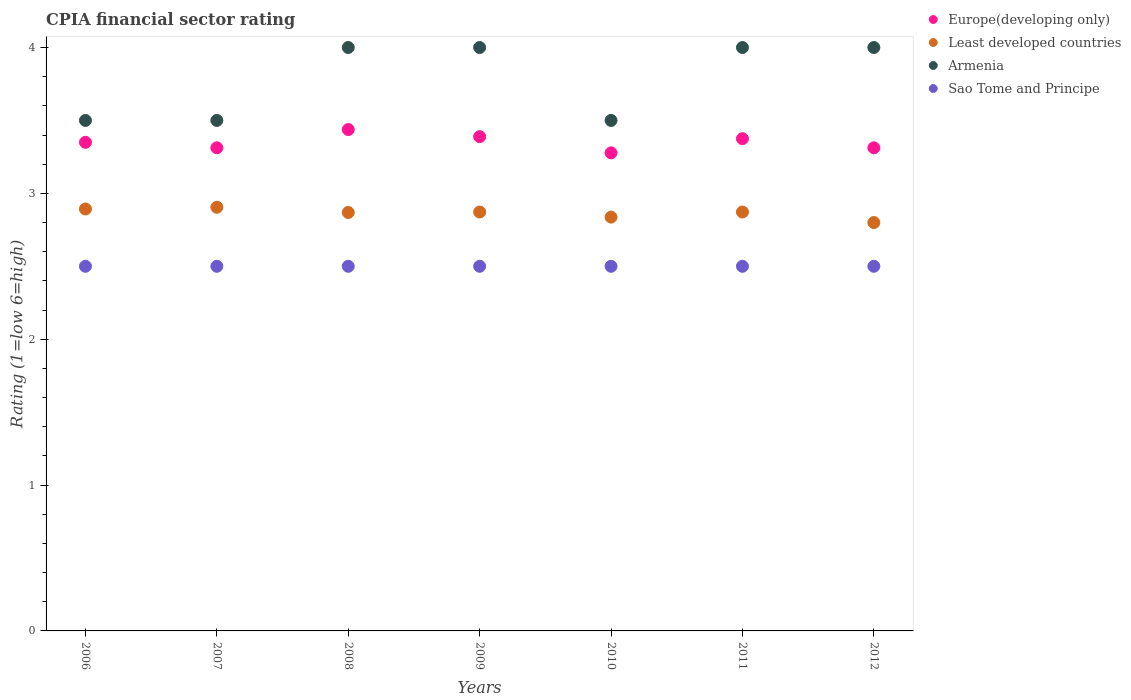What is the CPIA rating in Least developed countries in 2006?
Offer a very short reply. 2.89. Across all years, what is the maximum CPIA rating in Europe(developing only)?
Keep it short and to the point. 3.44. In which year was the CPIA rating in Europe(developing only) maximum?
Offer a very short reply. 2008. In which year was the CPIA rating in Sao Tome and Principe minimum?
Your answer should be compact. 2006. What is the total CPIA rating in Europe(developing only) in the graph?
Make the answer very short. 23.45. What is the difference between the CPIA rating in Sao Tome and Principe in 2007 and that in 2009?
Make the answer very short. 0. What is the difference between the CPIA rating in Armenia in 2011 and the CPIA rating in Sao Tome and Principe in 2012?
Your answer should be compact. 1.5. What is the average CPIA rating in Sao Tome and Principe per year?
Offer a terse response. 2.5. In the year 2009, what is the difference between the CPIA rating in Europe(developing only) and CPIA rating in Least developed countries?
Provide a succinct answer. 0.52. In how many years, is the CPIA rating in Sao Tome and Principe greater than 0.4?
Your answer should be compact. 7. What is the ratio of the CPIA rating in Europe(developing only) in 2006 to that in 2007?
Your response must be concise. 1.01. Is the CPIA rating in Armenia in 2006 less than that in 2011?
Your response must be concise. Yes. Is the difference between the CPIA rating in Europe(developing only) in 2010 and 2011 greater than the difference between the CPIA rating in Least developed countries in 2010 and 2011?
Ensure brevity in your answer.  No. What is the difference between the highest and the second highest CPIA rating in Armenia?
Your response must be concise. 0. What is the difference between the highest and the lowest CPIA rating in Europe(developing only)?
Your answer should be very brief. 0.16. In how many years, is the CPIA rating in Europe(developing only) greater than the average CPIA rating in Europe(developing only) taken over all years?
Ensure brevity in your answer.  3. Is it the case that in every year, the sum of the CPIA rating in Sao Tome and Principe and CPIA rating in Europe(developing only)  is greater than the CPIA rating in Armenia?
Your response must be concise. Yes. Does the CPIA rating in Armenia monotonically increase over the years?
Offer a terse response. No. How many dotlines are there?
Your answer should be very brief. 4. What is the difference between two consecutive major ticks on the Y-axis?
Provide a short and direct response. 1. Are the values on the major ticks of Y-axis written in scientific E-notation?
Ensure brevity in your answer.  No. How many legend labels are there?
Your response must be concise. 4. What is the title of the graph?
Make the answer very short. CPIA financial sector rating. Does "World" appear as one of the legend labels in the graph?
Your answer should be very brief. No. What is the Rating (1=low 6=high) in Europe(developing only) in 2006?
Offer a very short reply. 3.35. What is the Rating (1=low 6=high) in Least developed countries in 2006?
Provide a short and direct response. 2.89. What is the Rating (1=low 6=high) in Europe(developing only) in 2007?
Make the answer very short. 3.31. What is the Rating (1=low 6=high) in Least developed countries in 2007?
Provide a short and direct response. 2.9. What is the Rating (1=low 6=high) of Sao Tome and Principe in 2007?
Your response must be concise. 2.5. What is the Rating (1=low 6=high) in Europe(developing only) in 2008?
Offer a terse response. 3.44. What is the Rating (1=low 6=high) in Least developed countries in 2008?
Ensure brevity in your answer.  2.87. What is the Rating (1=low 6=high) in Sao Tome and Principe in 2008?
Your answer should be compact. 2.5. What is the Rating (1=low 6=high) of Europe(developing only) in 2009?
Offer a very short reply. 3.39. What is the Rating (1=low 6=high) of Least developed countries in 2009?
Your response must be concise. 2.87. What is the Rating (1=low 6=high) of Sao Tome and Principe in 2009?
Keep it short and to the point. 2.5. What is the Rating (1=low 6=high) of Europe(developing only) in 2010?
Keep it short and to the point. 3.28. What is the Rating (1=low 6=high) in Least developed countries in 2010?
Keep it short and to the point. 2.84. What is the Rating (1=low 6=high) of Armenia in 2010?
Your response must be concise. 3.5. What is the Rating (1=low 6=high) of Europe(developing only) in 2011?
Provide a succinct answer. 3.38. What is the Rating (1=low 6=high) of Least developed countries in 2011?
Provide a succinct answer. 2.87. What is the Rating (1=low 6=high) in Armenia in 2011?
Offer a terse response. 4. What is the Rating (1=low 6=high) in Sao Tome and Principe in 2011?
Your response must be concise. 2.5. What is the Rating (1=low 6=high) in Europe(developing only) in 2012?
Make the answer very short. 3.31. What is the Rating (1=low 6=high) in Least developed countries in 2012?
Make the answer very short. 2.8. What is the Rating (1=low 6=high) in Armenia in 2012?
Offer a terse response. 4. Across all years, what is the maximum Rating (1=low 6=high) of Europe(developing only)?
Offer a terse response. 3.44. Across all years, what is the maximum Rating (1=low 6=high) in Least developed countries?
Your answer should be compact. 2.9. Across all years, what is the minimum Rating (1=low 6=high) of Europe(developing only)?
Ensure brevity in your answer.  3.28. Across all years, what is the minimum Rating (1=low 6=high) in Least developed countries?
Give a very brief answer. 2.8. Across all years, what is the minimum Rating (1=low 6=high) of Armenia?
Your response must be concise. 3.5. Across all years, what is the minimum Rating (1=low 6=high) in Sao Tome and Principe?
Provide a short and direct response. 2.5. What is the total Rating (1=low 6=high) of Europe(developing only) in the graph?
Keep it short and to the point. 23.45. What is the total Rating (1=low 6=high) of Least developed countries in the graph?
Provide a short and direct response. 20.05. What is the total Rating (1=low 6=high) in Armenia in the graph?
Offer a very short reply. 26.5. What is the total Rating (1=low 6=high) of Sao Tome and Principe in the graph?
Make the answer very short. 17.5. What is the difference between the Rating (1=low 6=high) of Europe(developing only) in 2006 and that in 2007?
Offer a very short reply. 0.04. What is the difference between the Rating (1=low 6=high) in Least developed countries in 2006 and that in 2007?
Provide a succinct answer. -0.01. What is the difference between the Rating (1=low 6=high) of Europe(developing only) in 2006 and that in 2008?
Offer a very short reply. -0.09. What is the difference between the Rating (1=low 6=high) of Least developed countries in 2006 and that in 2008?
Provide a succinct answer. 0.02. What is the difference between the Rating (1=low 6=high) in Sao Tome and Principe in 2006 and that in 2008?
Your response must be concise. 0. What is the difference between the Rating (1=low 6=high) in Europe(developing only) in 2006 and that in 2009?
Ensure brevity in your answer.  -0.04. What is the difference between the Rating (1=low 6=high) in Least developed countries in 2006 and that in 2009?
Offer a very short reply. 0.02. What is the difference between the Rating (1=low 6=high) of Armenia in 2006 and that in 2009?
Provide a succinct answer. -0.5. What is the difference between the Rating (1=low 6=high) of Sao Tome and Principe in 2006 and that in 2009?
Ensure brevity in your answer.  0. What is the difference between the Rating (1=low 6=high) of Europe(developing only) in 2006 and that in 2010?
Keep it short and to the point. 0.07. What is the difference between the Rating (1=low 6=high) of Least developed countries in 2006 and that in 2010?
Your answer should be very brief. 0.06. What is the difference between the Rating (1=low 6=high) of Europe(developing only) in 2006 and that in 2011?
Provide a succinct answer. -0.03. What is the difference between the Rating (1=low 6=high) of Least developed countries in 2006 and that in 2011?
Your answer should be very brief. 0.02. What is the difference between the Rating (1=low 6=high) of Sao Tome and Principe in 2006 and that in 2011?
Ensure brevity in your answer.  0. What is the difference between the Rating (1=low 6=high) in Europe(developing only) in 2006 and that in 2012?
Make the answer very short. 0.04. What is the difference between the Rating (1=low 6=high) in Least developed countries in 2006 and that in 2012?
Your answer should be compact. 0.09. What is the difference between the Rating (1=low 6=high) of Armenia in 2006 and that in 2012?
Make the answer very short. -0.5. What is the difference between the Rating (1=low 6=high) in Sao Tome and Principe in 2006 and that in 2012?
Your answer should be very brief. 0. What is the difference between the Rating (1=low 6=high) of Europe(developing only) in 2007 and that in 2008?
Ensure brevity in your answer.  -0.12. What is the difference between the Rating (1=low 6=high) in Least developed countries in 2007 and that in 2008?
Provide a succinct answer. 0.04. What is the difference between the Rating (1=low 6=high) of Armenia in 2007 and that in 2008?
Offer a terse response. -0.5. What is the difference between the Rating (1=low 6=high) of Europe(developing only) in 2007 and that in 2009?
Keep it short and to the point. -0.08. What is the difference between the Rating (1=low 6=high) in Least developed countries in 2007 and that in 2009?
Your answer should be very brief. 0.03. What is the difference between the Rating (1=low 6=high) of Armenia in 2007 and that in 2009?
Your response must be concise. -0.5. What is the difference between the Rating (1=low 6=high) in Europe(developing only) in 2007 and that in 2010?
Your response must be concise. 0.03. What is the difference between the Rating (1=low 6=high) in Least developed countries in 2007 and that in 2010?
Ensure brevity in your answer.  0.07. What is the difference between the Rating (1=low 6=high) in Sao Tome and Principe in 2007 and that in 2010?
Your answer should be very brief. 0. What is the difference between the Rating (1=low 6=high) of Europe(developing only) in 2007 and that in 2011?
Provide a short and direct response. -0.06. What is the difference between the Rating (1=low 6=high) of Least developed countries in 2007 and that in 2011?
Make the answer very short. 0.03. What is the difference between the Rating (1=low 6=high) of Europe(developing only) in 2007 and that in 2012?
Provide a short and direct response. 0. What is the difference between the Rating (1=low 6=high) of Least developed countries in 2007 and that in 2012?
Keep it short and to the point. 0.1. What is the difference between the Rating (1=low 6=high) in Armenia in 2007 and that in 2012?
Offer a terse response. -0.5. What is the difference between the Rating (1=low 6=high) of Europe(developing only) in 2008 and that in 2009?
Keep it short and to the point. 0.05. What is the difference between the Rating (1=low 6=high) of Least developed countries in 2008 and that in 2009?
Your answer should be very brief. -0. What is the difference between the Rating (1=low 6=high) in Sao Tome and Principe in 2008 and that in 2009?
Offer a very short reply. 0. What is the difference between the Rating (1=low 6=high) in Europe(developing only) in 2008 and that in 2010?
Make the answer very short. 0.16. What is the difference between the Rating (1=low 6=high) in Least developed countries in 2008 and that in 2010?
Keep it short and to the point. 0.03. What is the difference between the Rating (1=low 6=high) in Armenia in 2008 and that in 2010?
Keep it short and to the point. 0.5. What is the difference between the Rating (1=low 6=high) of Europe(developing only) in 2008 and that in 2011?
Provide a succinct answer. 0.06. What is the difference between the Rating (1=low 6=high) of Least developed countries in 2008 and that in 2011?
Keep it short and to the point. -0. What is the difference between the Rating (1=low 6=high) in Sao Tome and Principe in 2008 and that in 2011?
Your response must be concise. 0. What is the difference between the Rating (1=low 6=high) of Europe(developing only) in 2008 and that in 2012?
Provide a succinct answer. 0.12. What is the difference between the Rating (1=low 6=high) in Least developed countries in 2008 and that in 2012?
Give a very brief answer. 0.07. What is the difference between the Rating (1=low 6=high) of Armenia in 2008 and that in 2012?
Ensure brevity in your answer.  0. What is the difference between the Rating (1=low 6=high) in Sao Tome and Principe in 2008 and that in 2012?
Your answer should be compact. 0. What is the difference between the Rating (1=low 6=high) in Least developed countries in 2009 and that in 2010?
Your answer should be very brief. 0.03. What is the difference between the Rating (1=low 6=high) in Armenia in 2009 and that in 2010?
Your answer should be compact. 0.5. What is the difference between the Rating (1=low 6=high) in Europe(developing only) in 2009 and that in 2011?
Your answer should be very brief. 0.01. What is the difference between the Rating (1=low 6=high) in Least developed countries in 2009 and that in 2011?
Offer a very short reply. 0. What is the difference between the Rating (1=low 6=high) of Armenia in 2009 and that in 2011?
Make the answer very short. 0. What is the difference between the Rating (1=low 6=high) in Sao Tome and Principe in 2009 and that in 2011?
Provide a succinct answer. 0. What is the difference between the Rating (1=low 6=high) in Europe(developing only) in 2009 and that in 2012?
Make the answer very short. 0.08. What is the difference between the Rating (1=low 6=high) in Least developed countries in 2009 and that in 2012?
Your response must be concise. 0.07. What is the difference between the Rating (1=low 6=high) of Armenia in 2009 and that in 2012?
Provide a short and direct response. 0. What is the difference between the Rating (1=low 6=high) in Europe(developing only) in 2010 and that in 2011?
Your answer should be compact. -0.1. What is the difference between the Rating (1=low 6=high) in Least developed countries in 2010 and that in 2011?
Your response must be concise. -0.03. What is the difference between the Rating (1=low 6=high) in Armenia in 2010 and that in 2011?
Provide a short and direct response. -0.5. What is the difference between the Rating (1=low 6=high) of Sao Tome and Principe in 2010 and that in 2011?
Your answer should be very brief. 0. What is the difference between the Rating (1=low 6=high) of Europe(developing only) in 2010 and that in 2012?
Your answer should be compact. -0.03. What is the difference between the Rating (1=low 6=high) of Least developed countries in 2010 and that in 2012?
Offer a very short reply. 0.04. What is the difference between the Rating (1=low 6=high) of Europe(developing only) in 2011 and that in 2012?
Provide a short and direct response. 0.06. What is the difference between the Rating (1=low 6=high) in Least developed countries in 2011 and that in 2012?
Your answer should be very brief. 0.07. What is the difference between the Rating (1=low 6=high) in Europe(developing only) in 2006 and the Rating (1=low 6=high) in Least developed countries in 2007?
Make the answer very short. 0.45. What is the difference between the Rating (1=low 6=high) in Least developed countries in 2006 and the Rating (1=low 6=high) in Armenia in 2007?
Provide a short and direct response. -0.61. What is the difference between the Rating (1=low 6=high) of Least developed countries in 2006 and the Rating (1=low 6=high) of Sao Tome and Principe in 2007?
Make the answer very short. 0.39. What is the difference between the Rating (1=low 6=high) in Europe(developing only) in 2006 and the Rating (1=low 6=high) in Least developed countries in 2008?
Offer a very short reply. 0.48. What is the difference between the Rating (1=low 6=high) in Europe(developing only) in 2006 and the Rating (1=low 6=high) in Armenia in 2008?
Ensure brevity in your answer.  -0.65. What is the difference between the Rating (1=low 6=high) of Europe(developing only) in 2006 and the Rating (1=low 6=high) of Sao Tome and Principe in 2008?
Keep it short and to the point. 0.85. What is the difference between the Rating (1=low 6=high) of Least developed countries in 2006 and the Rating (1=low 6=high) of Armenia in 2008?
Your answer should be very brief. -1.11. What is the difference between the Rating (1=low 6=high) in Least developed countries in 2006 and the Rating (1=low 6=high) in Sao Tome and Principe in 2008?
Make the answer very short. 0.39. What is the difference between the Rating (1=low 6=high) in Armenia in 2006 and the Rating (1=low 6=high) in Sao Tome and Principe in 2008?
Offer a very short reply. 1. What is the difference between the Rating (1=low 6=high) of Europe(developing only) in 2006 and the Rating (1=low 6=high) of Least developed countries in 2009?
Provide a succinct answer. 0.48. What is the difference between the Rating (1=low 6=high) of Europe(developing only) in 2006 and the Rating (1=low 6=high) of Armenia in 2009?
Keep it short and to the point. -0.65. What is the difference between the Rating (1=low 6=high) of Least developed countries in 2006 and the Rating (1=low 6=high) of Armenia in 2009?
Make the answer very short. -1.11. What is the difference between the Rating (1=low 6=high) of Least developed countries in 2006 and the Rating (1=low 6=high) of Sao Tome and Principe in 2009?
Provide a short and direct response. 0.39. What is the difference between the Rating (1=low 6=high) of Armenia in 2006 and the Rating (1=low 6=high) of Sao Tome and Principe in 2009?
Your answer should be very brief. 1. What is the difference between the Rating (1=low 6=high) of Europe(developing only) in 2006 and the Rating (1=low 6=high) of Least developed countries in 2010?
Provide a succinct answer. 0.51. What is the difference between the Rating (1=low 6=high) in Europe(developing only) in 2006 and the Rating (1=low 6=high) in Armenia in 2010?
Offer a very short reply. -0.15. What is the difference between the Rating (1=low 6=high) in Least developed countries in 2006 and the Rating (1=low 6=high) in Armenia in 2010?
Provide a succinct answer. -0.61. What is the difference between the Rating (1=low 6=high) of Least developed countries in 2006 and the Rating (1=low 6=high) of Sao Tome and Principe in 2010?
Make the answer very short. 0.39. What is the difference between the Rating (1=low 6=high) in Armenia in 2006 and the Rating (1=low 6=high) in Sao Tome and Principe in 2010?
Ensure brevity in your answer.  1. What is the difference between the Rating (1=low 6=high) of Europe(developing only) in 2006 and the Rating (1=low 6=high) of Least developed countries in 2011?
Give a very brief answer. 0.48. What is the difference between the Rating (1=low 6=high) of Europe(developing only) in 2006 and the Rating (1=low 6=high) of Armenia in 2011?
Give a very brief answer. -0.65. What is the difference between the Rating (1=low 6=high) of Europe(developing only) in 2006 and the Rating (1=low 6=high) of Sao Tome and Principe in 2011?
Make the answer very short. 0.85. What is the difference between the Rating (1=low 6=high) of Least developed countries in 2006 and the Rating (1=low 6=high) of Armenia in 2011?
Offer a very short reply. -1.11. What is the difference between the Rating (1=low 6=high) of Least developed countries in 2006 and the Rating (1=low 6=high) of Sao Tome and Principe in 2011?
Your answer should be very brief. 0.39. What is the difference between the Rating (1=low 6=high) of Europe(developing only) in 2006 and the Rating (1=low 6=high) of Least developed countries in 2012?
Make the answer very short. 0.55. What is the difference between the Rating (1=low 6=high) of Europe(developing only) in 2006 and the Rating (1=low 6=high) of Armenia in 2012?
Your answer should be compact. -0.65. What is the difference between the Rating (1=low 6=high) of Europe(developing only) in 2006 and the Rating (1=low 6=high) of Sao Tome and Principe in 2012?
Offer a terse response. 0.85. What is the difference between the Rating (1=low 6=high) of Least developed countries in 2006 and the Rating (1=low 6=high) of Armenia in 2012?
Ensure brevity in your answer.  -1.11. What is the difference between the Rating (1=low 6=high) in Least developed countries in 2006 and the Rating (1=low 6=high) in Sao Tome and Principe in 2012?
Your answer should be very brief. 0.39. What is the difference between the Rating (1=low 6=high) in Armenia in 2006 and the Rating (1=low 6=high) in Sao Tome and Principe in 2012?
Your answer should be very brief. 1. What is the difference between the Rating (1=low 6=high) in Europe(developing only) in 2007 and the Rating (1=low 6=high) in Least developed countries in 2008?
Provide a short and direct response. 0.44. What is the difference between the Rating (1=low 6=high) of Europe(developing only) in 2007 and the Rating (1=low 6=high) of Armenia in 2008?
Make the answer very short. -0.69. What is the difference between the Rating (1=low 6=high) in Europe(developing only) in 2007 and the Rating (1=low 6=high) in Sao Tome and Principe in 2008?
Your answer should be compact. 0.81. What is the difference between the Rating (1=low 6=high) of Least developed countries in 2007 and the Rating (1=low 6=high) of Armenia in 2008?
Provide a succinct answer. -1.1. What is the difference between the Rating (1=low 6=high) of Least developed countries in 2007 and the Rating (1=low 6=high) of Sao Tome and Principe in 2008?
Your response must be concise. 0.4. What is the difference between the Rating (1=low 6=high) of Europe(developing only) in 2007 and the Rating (1=low 6=high) of Least developed countries in 2009?
Your answer should be very brief. 0.44. What is the difference between the Rating (1=low 6=high) of Europe(developing only) in 2007 and the Rating (1=low 6=high) of Armenia in 2009?
Provide a succinct answer. -0.69. What is the difference between the Rating (1=low 6=high) in Europe(developing only) in 2007 and the Rating (1=low 6=high) in Sao Tome and Principe in 2009?
Ensure brevity in your answer.  0.81. What is the difference between the Rating (1=low 6=high) of Least developed countries in 2007 and the Rating (1=low 6=high) of Armenia in 2009?
Your answer should be very brief. -1.1. What is the difference between the Rating (1=low 6=high) in Least developed countries in 2007 and the Rating (1=low 6=high) in Sao Tome and Principe in 2009?
Your response must be concise. 0.4. What is the difference between the Rating (1=low 6=high) of Europe(developing only) in 2007 and the Rating (1=low 6=high) of Least developed countries in 2010?
Your response must be concise. 0.48. What is the difference between the Rating (1=low 6=high) of Europe(developing only) in 2007 and the Rating (1=low 6=high) of Armenia in 2010?
Offer a very short reply. -0.19. What is the difference between the Rating (1=low 6=high) in Europe(developing only) in 2007 and the Rating (1=low 6=high) in Sao Tome and Principe in 2010?
Make the answer very short. 0.81. What is the difference between the Rating (1=low 6=high) of Least developed countries in 2007 and the Rating (1=low 6=high) of Armenia in 2010?
Make the answer very short. -0.6. What is the difference between the Rating (1=low 6=high) of Least developed countries in 2007 and the Rating (1=low 6=high) of Sao Tome and Principe in 2010?
Offer a very short reply. 0.4. What is the difference between the Rating (1=low 6=high) in Europe(developing only) in 2007 and the Rating (1=low 6=high) in Least developed countries in 2011?
Make the answer very short. 0.44. What is the difference between the Rating (1=low 6=high) of Europe(developing only) in 2007 and the Rating (1=low 6=high) of Armenia in 2011?
Keep it short and to the point. -0.69. What is the difference between the Rating (1=low 6=high) of Europe(developing only) in 2007 and the Rating (1=low 6=high) of Sao Tome and Principe in 2011?
Your answer should be compact. 0.81. What is the difference between the Rating (1=low 6=high) of Least developed countries in 2007 and the Rating (1=low 6=high) of Armenia in 2011?
Ensure brevity in your answer.  -1.1. What is the difference between the Rating (1=low 6=high) in Least developed countries in 2007 and the Rating (1=low 6=high) in Sao Tome and Principe in 2011?
Your answer should be very brief. 0.4. What is the difference between the Rating (1=low 6=high) of Armenia in 2007 and the Rating (1=low 6=high) of Sao Tome and Principe in 2011?
Give a very brief answer. 1. What is the difference between the Rating (1=low 6=high) of Europe(developing only) in 2007 and the Rating (1=low 6=high) of Least developed countries in 2012?
Ensure brevity in your answer.  0.51. What is the difference between the Rating (1=low 6=high) in Europe(developing only) in 2007 and the Rating (1=low 6=high) in Armenia in 2012?
Offer a very short reply. -0.69. What is the difference between the Rating (1=low 6=high) of Europe(developing only) in 2007 and the Rating (1=low 6=high) of Sao Tome and Principe in 2012?
Your answer should be very brief. 0.81. What is the difference between the Rating (1=low 6=high) in Least developed countries in 2007 and the Rating (1=low 6=high) in Armenia in 2012?
Offer a very short reply. -1.1. What is the difference between the Rating (1=low 6=high) of Least developed countries in 2007 and the Rating (1=low 6=high) of Sao Tome and Principe in 2012?
Your response must be concise. 0.4. What is the difference between the Rating (1=low 6=high) in Armenia in 2007 and the Rating (1=low 6=high) in Sao Tome and Principe in 2012?
Ensure brevity in your answer.  1. What is the difference between the Rating (1=low 6=high) of Europe(developing only) in 2008 and the Rating (1=low 6=high) of Least developed countries in 2009?
Your answer should be compact. 0.57. What is the difference between the Rating (1=low 6=high) in Europe(developing only) in 2008 and the Rating (1=low 6=high) in Armenia in 2009?
Offer a terse response. -0.56. What is the difference between the Rating (1=low 6=high) in Europe(developing only) in 2008 and the Rating (1=low 6=high) in Sao Tome and Principe in 2009?
Give a very brief answer. 0.94. What is the difference between the Rating (1=low 6=high) of Least developed countries in 2008 and the Rating (1=low 6=high) of Armenia in 2009?
Offer a very short reply. -1.13. What is the difference between the Rating (1=low 6=high) in Least developed countries in 2008 and the Rating (1=low 6=high) in Sao Tome and Principe in 2009?
Offer a very short reply. 0.37. What is the difference between the Rating (1=low 6=high) of Armenia in 2008 and the Rating (1=low 6=high) of Sao Tome and Principe in 2009?
Give a very brief answer. 1.5. What is the difference between the Rating (1=low 6=high) in Europe(developing only) in 2008 and the Rating (1=low 6=high) in Least developed countries in 2010?
Your response must be concise. 0.6. What is the difference between the Rating (1=low 6=high) of Europe(developing only) in 2008 and the Rating (1=low 6=high) of Armenia in 2010?
Provide a short and direct response. -0.06. What is the difference between the Rating (1=low 6=high) in Europe(developing only) in 2008 and the Rating (1=low 6=high) in Sao Tome and Principe in 2010?
Your answer should be very brief. 0.94. What is the difference between the Rating (1=low 6=high) of Least developed countries in 2008 and the Rating (1=low 6=high) of Armenia in 2010?
Provide a succinct answer. -0.63. What is the difference between the Rating (1=low 6=high) in Least developed countries in 2008 and the Rating (1=low 6=high) in Sao Tome and Principe in 2010?
Give a very brief answer. 0.37. What is the difference between the Rating (1=low 6=high) in Armenia in 2008 and the Rating (1=low 6=high) in Sao Tome and Principe in 2010?
Make the answer very short. 1.5. What is the difference between the Rating (1=low 6=high) of Europe(developing only) in 2008 and the Rating (1=low 6=high) of Least developed countries in 2011?
Offer a very short reply. 0.57. What is the difference between the Rating (1=low 6=high) of Europe(developing only) in 2008 and the Rating (1=low 6=high) of Armenia in 2011?
Your response must be concise. -0.56. What is the difference between the Rating (1=low 6=high) of Least developed countries in 2008 and the Rating (1=low 6=high) of Armenia in 2011?
Make the answer very short. -1.13. What is the difference between the Rating (1=low 6=high) in Least developed countries in 2008 and the Rating (1=low 6=high) in Sao Tome and Principe in 2011?
Give a very brief answer. 0.37. What is the difference between the Rating (1=low 6=high) of Armenia in 2008 and the Rating (1=low 6=high) of Sao Tome and Principe in 2011?
Provide a short and direct response. 1.5. What is the difference between the Rating (1=low 6=high) of Europe(developing only) in 2008 and the Rating (1=low 6=high) of Least developed countries in 2012?
Provide a short and direct response. 0.64. What is the difference between the Rating (1=low 6=high) of Europe(developing only) in 2008 and the Rating (1=low 6=high) of Armenia in 2012?
Offer a very short reply. -0.56. What is the difference between the Rating (1=low 6=high) in Least developed countries in 2008 and the Rating (1=low 6=high) in Armenia in 2012?
Ensure brevity in your answer.  -1.13. What is the difference between the Rating (1=low 6=high) of Least developed countries in 2008 and the Rating (1=low 6=high) of Sao Tome and Principe in 2012?
Your answer should be very brief. 0.37. What is the difference between the Rating (1=low 6=high) of Europe(developing only) in 2009 and the Rating (1=low 6=high) of Least developed countries in 2010?
Your answer should be very brief. 0.55. What is the difference between the Rating (1=low 6=high) of Europe(developing only) in 2009 and the Rating (1=low 6=high) of Armenia in 2010?
Provide a succinct answer. -0.11. What is the difference between the Rating (1=low 6=high) in Least developed countries in 2009 and the Rating (1=low 6=high) in Armenia in 2010?
Ensure brevity in your answer.  -0.63. What is the difference between the Rating (1=low 6=high) in Least developed countries in 2009 and the Rating (1=low 6=high) in Sao Tome and Principe in 2010?
Give a very brief answer. 0.37. What is the difference between the Rating (1=low 6=high) in Europe(developing only) in 2009 and the Rating (1=low 6=high) in Least developed countries in 2011?
Offer a terse response. 0.52. What is the difference between the Rating (1=low 6=high) of Europe(developing only) in 2009 and the Rating (1=low 6=high) of Armenia in 2011?
Offer a very short reply. -0.61. What is the difference between the Rating (1=low 6=high) of Europe(developing only) in 2009 and the Rating (1=low 6=high) of Sao Tome and Principe in 2011?
Ensure brevity in your answer.  0.89. What is the difference between the Rating (1=low 6=high) of Least developed countries in 2009 and the Rating (1=low 6=high) of Armenia in 2011?
Your answer should be compact. -1.13. What is the difference between the Rating (1=low 6=high) of Least developed countries in 2009 and the Rating (1=low 6=high) of Sao Tome and Principe in 2011?
Ensure brevity in your answer.  0.37. What is the difference between the Rating (1=low 6=high) of Armenia in 2009 and the Rating (1=low 6=high) of Sao Tome and Principe in 2011?
Provide a short and direct response. 1.5. What is the difference between the Rating (1=low 6=high) of Europe(developing only) in 2009 and the Rating (1=low 6=high) of Least developed countries in 2012?
Offer a terse response. 0.59. What is the difference between the Rating (1=low 6=high) in Europe(developing only) in 2009 and the Rating (1=low 6=high) in Armenia in 2012?
Give a very brief answer. -0.61. What is the difference between the Rating (1=low 6=high) of Least developed countries in 2009 and the Rating (1=low 6=high) of Armenia in 2012?
Provide a succinct answer. -1.13. What is the difference between the Rating (1=low 6=high) of Least developed countries in 2009 and the Rating (1=low 6=high) of Sao Tome and Principe in 2012?
Provide a succinct answer. 0.37. What is the difference between the Rating (1=low 6=high) in Europe(developing only) in 2010 and the Rating (1=low 6=high) in Least developed countries in 2011?
Keep it short and to the point. 0.41. What is the difference between the Rating (1=low 6=high) in Europe(developing only) in 2010 and the Rating (1=low 6=high) in Armenia in 2011?
Keep it short and to the point. -0.72. What is the difference between the Rating (1=low 6=high) in Europe(developing only) in 2010 and the Rating (1=low 6=high) in Sao Tome and Principe in 2011?
Your answer should be very brief. 0.78. What is the difference between the Rating (1=low 6=high) of Least developed countries in 2010 and the Rating (1=low 6=high) of Armenia in 2011?
Offer a terse response. -1.16. What is the difference between the Rating (1=low 6=high) of Least developed countries in 2010 and the Rating (1=low 6=high) of Sao Tome and Principe in 2011?
Provide a succinct answer. 0.34. What is the difference between the Rating (1=low 6=high) in Armenia in 2010 and the Rating (1=low 6=high) in Sao Tome and Principe in 2011?
Provide a short and direct response. 1. What is the difference between the Rating (1=low 6=high) in Europe(developing only) in 2010 and the Rating (1=low 6=high) in Least developed countries in 2012?
Offer a very short reply. 0.48. What is the difference between the Rating (1=low 6=high) in Europe(developing only) in 2010 and the Rating (1=low 6=high) in Armenia in 2012?
Make the answer very short. -0.72. What is the difference between the Rating (1=low 6=high) of Least developed countries in 2010 and the Rating (1=low 6=high) of Armenia in 2012?
Your answer should be very brief. -1.16. What is the difference between the Rating (1=low 6=high) of Least developed countries in 2010 and the Rating (1=low 6=high) of Sao Tome and Principe in 2012?
Provide a short and direct response. 0.34. What is the difference between the Rating (1=low 6=high) of Europe(developing only) in 2011 and the Rating (1=low 6=high) of Least developed countries in 2012?
Offer a very short reply. 0.57. What is the difference between the Rating (1=low 6=high) in Europe(developing only) in 2011 and the Rating (1=low 6=high) in Armenia in 2012?
Ensure brevity in your answer.  -0.62. What is the difference between the Rating (1=low 6=high) in Least developed countries in 2011 and the Rating (1=low 6=high) in Armenia in 2012?
Your response must be concise. -1.13. What is the difference between the Rating (1=low 6=high) of Least developed countries in 2011 and the Rating (1=low 6=high) of Sao Tome and Principe in 2012?
Offer a very short reply. 0.37. What is the average Rating (1=low 6=high) of Europe(developing only) per year?
Provide a succinct answer. 3.35. What is the average Rating (1=low 6=high) in Least developed countries per year?
Your answer should be very brief. 2.86. What is the average Rating (1=low 6=high) of Armenia per year?
Make the answer very short. 3.79. What is the average Rating (1=low 6=high) in Sao Tome and Principe per year?
Give a very brief answer. 2.5. In the year 2006, what is the difference between the Rating (1=low 6=high) in Europe(developing only) and Rating (1=low 6=high) in Least developed countries?
Give a very brief answer. 0.46. In the year 2006, what is the difference between the Rating (1=low 6=high) of Europe(developing only) and Rating (1=low 6=high) of Armenia?
Your answer should be compact. -0.15. In the year 2006, what is the difference between the Rating (1=low 6=high) in Least developed countries and Rating (1=low 6=high) in Armenia?
Offer a very short reply. -0.61. In the year 2006, what is the difference between the Rating (1=low 6=high) of Least developed countries and Rating (1=low 6=high) of Sao Tome and Principe?
Give a very brief answer. 0.39. In the year 2007, what is the difference between the Rating (1=low 6=high) of Europe(developing only) and Rating (1=low 6=high) of Least developed countries?
Keep it short and to the point. 0.41. In the year 2007, what is the difference between the Rating (1=low 6=high) in Europe(developing only) and Rating (1=low 6=high) in Armenia?
Your response must be concise. -0.19. In the year 2007, what is the difference between the Rating (1=low 6=high) of Europe(developing only) and Rating (1=low 6=high) of Sao Tome and Principe?
Your answer should be very brief. 0.81. In the year 2007, what is the difference between the Rating (1=low 6=high) of Least developed countries and Rating (1=low 6=high) of Armenia?
Provide a succinct answer. -0.6. In the year 2007, what is the difference between the Rating (1=low 6=high) in Least developed countries and Rating (1=low 6=high) in Sao Tome and Principe?
Your answer should be compact. 0.4. In the year 2007, what is the difference between the Rating (1=low 6=high) of Armenia and Rating (1=low 6=high) of Sao Tome and Principe?
Offer a terse response. 1. In the year 2008, what is the difference between the Rating (1=low 6=high) of Europe(developing only) and Rating (1=low 6=high) of Least developed countries?
Your answer should be compact. 0.57. In the year 2008, what is the difference between the Rating (1=low 6=high) in Europe(developing only) and Rating (1=low 6=high) in Armenia?
Offer a very short reply. -0.56. In the year 2008, what is the difference between the Rating (1=low 6=high) in Least developed countries and Rating (1=low 6=high) in Armenia?
Offer a terse response. -1.13. In the year 2008, what is the difference between the Rating (1=low 6=high) in Least developed countries and Rating (1=low 6=high) in Sao Tome and Principe?
Your answer should be very brief. 0.37. In the year 2009, what is the difference between the Rating (1=low 6=high) in Europe(developing only) and Rating (1=low 6=high) in Least developed countries?
Ensure brevity in your answer.  0.52. In the year 2009, what is the difference between the Rating (1=low 6=high) of Europe(developing only) and Rating (1=low 6=high) of Armenia?
Ensure brevity in your answer.  -0.61. In the year 2009, what is the difference between the Rating (1=low 6=high) in Least developed countries and Rating (1=low 6=high) in Armenia?
Give a very brief answer. -1.13. In the year 2009, what is the difference between the Rating (1=low 6=high) in Least developed countries and Rating (1=low 6=high) in Sao Tome and Principe?
Your response must be concise. 0.37. In the year 2010, what is the difference between the Rating (1=low 6=high) of Europe(developing only) and Rating (1=low 6=high) of Least developed countries?
Ensure brevity in your answer.  0.44. In the year 2010, what is the difference between the Rating (1=low 6=high) in Europe(developing only) and Rating (1=low 6=high) in Armenia?
Make the answer very short. -0.22. In the year 2010, what is the difference between the Rating (1=low 6=high) of Europe(developing only) and Rating (1=low 6=high) of Sao Tome and Principe?
Ensure brevity in your answer.  0.78. In the year 2010, what is the difference between the Rating (1=low 6=high) in Least developed countries and Rating (1=low 6=high) in Armenia?
Make the answer very short. -0.66. In the year 2010, what is the difference between the Rating (1=low 6=high) of Least developed countries and Rating (1=low 6=high) of Sao Tome and Principe?
Provide a succinct answer. 0.34. In the year 2010, what is the difference between the Rating (1=low 6=high) of Armenia and Rating (1=low 6=high) of Sao Tome and Principe?
Your answer should be compact. 1. In the year 2011, what is the difference between the Rating (1=low 6=high) in Europe(developing only) and Rating (1=low 6=high) in Least developed countries?
Offer a terse response. 0.5. In the year 2011, what is the difference between the Rating (1=low 6=high) of Europe(developing only) and Rating (1=low 6=high) of Armenia?
Provide a short and direct response. -0.62. In the year 2011, what is the difference between the Rating (1=low 6=high) of Least developed countries and Rating (1=low 6=high) of Armenia?
Provide a succinct answer. -1.13. In the year 2011, what is the difference between the Rating (1=low 6=high) of Least developed countries and Rating (1=low 6=high) of Sao Tome and Principe?
Your response must be concise. 0.37. In the year 2011, what is the difference between the Rating (1=low 6=high) in Armenia and Rating (1=low 6=high) in Sao Tome and Principe?
Ensure brevity in your answer.  1.5. In the year 2012, what is the difference between the Rating (1=low 6=high) of Europe(developing only) and Rating (1=low 6=high) of Least developed countries?
Your answer should be very brief. 0.51. In the year 2012, what is the difference between the Rating (1=low 6=high) in Europe(developing only) and Rating (1=low 6=high) in Armenia?
Provide a short and direct response. -0.69. In the year 2012, what is the difference between the Rating (1=low 6=high) in Europe(developing only) and Rating (1=low 6=high) in Sao Tome and Principe?
Give a very brief answer. 0.81. In the year 2012, what is the difference between the Rating (1=low 6=high) in Least developed countries and Rating (1=low 6=high) in Armenia?
Provide a succinct answer. -1.2. What is the ratio of the Rating (1=low 6=high) of Europe(developing only) in 2006 to that in 2007?
Keep it short and to the point. 1.01. What is the ratio of the Rating (1=low 6=high) of Armenia in 2006 to that in 2007?
Your answer should be compact. 1. What is the ratio of the Rating (1=low 6=high) of Europe(developing only) in 2006 to that in 2008?
Offer a very short reply. 0.97. What is the ratio of the Rating (1=low 6=high) of Least developed countries in 2006 to that in 2008?
Give a very brief answer. 1.01. What is the ratio of the Rating (1=low 6=high) of Armenia in 2006 to that in 2008?
Give a very brief answer. 0.88. What is the ratio of the Rating (1=low 6=high) of Sao Tome and Principe in 2006 to that in 2008?
Offer a very short reply. 1. What is the ratio of the Rating (1=low 6=high) of Armenia in 2006 to that in 2009?
Your answer should be very brief. 0.88. What is the ratio of the Rating (1=low 6=high) in Sao Tome and Principe in 2006 to that in 2009?
Your response must be concise. 1. What is the ratio of the Rating (1=low 6=high) of Europe(developing only) in 2006 to that in 2010?
Keep it short and to the point. 1.02. What is the ratio of the Rating (1=low 6=high) of Least developed countries in 2006 to that in 2010?
Offer a very short reply. 1.02. What is the ratio of the Rating (1=low 6=high) of Sao Tome and Principe in 2006 to that in 2010?
Keep it short and to the point. 1. What is the ratio of the Rating (1=low 6=high) of Least developed countries in 2006 to that in 2011?
Provide a succinct answer. 1.01. What is the ratio of the Rating (1=low 6=high) of Armenia in 2006 to that in 2011?
Offer a very short reply. 0.88. What is the ratio of the Rating (1=low 6=high) of Europe(developing only) in 2006 to that in 2012?
Offer a very short reply. 1.01. What is the ratio of the Rating (1=low 6=high) in Least developed countries in 2006 to that in 2012?
Your response must be concise. 1.03. What is the ratio of the Rating (1=low 6=high) in Sao Tome and Principe in 2006 to that in 2012?
Provide a short and direct response. 1. What is the ratio of the Rating (1=low 6=high) of Europe(developing only) in 2007 to that in 2008?
Offer a very short reply. 0.96. What is the ratio of the Rating (1=low 6=high) of Least developed countries in 2007 to that in 2008?
Provide a succinct answer. 1.01. What is the ratio of the Rating (1=low 6=high) in Armenia in 2007 to that in 2008?
Offer a very short reply. 0.88. What is the ratio of the Rating (1=low 6=high) of Sao Tome and Principe in 2007 to that in 2008?
Provide a succinct answer. 1. What is the ratio of the Rating (1=low 6=high) in Europe(developing only) in 2007 to that in 2009?
Your response must be concise. 0.98. What is the ratio of the Rating (1=low 6=high) of Least developed countries in 2007 to that in 2009?
Give a very brief answer. 1.01. What is the ratio of the Rating (1=low 6=high) in Armenia in 2007 to that in 2009?
Keep it short and to the point. 0.88. What is the ratio of the Rating (1=low 6=high) in Sao Tome and Principe in 2007 to that in 2009?
Offer a very short reply. 1. What is the ratio of the Rating (1=low 6=high) of Europe(developing only) in 2007 to that in 2010?
Keep it short and to the point. 1.01. What is the ratio of the Rating (1=low 6=high) in Least developed countries in 2007 to that in 2010?
Offer a very short reply. 1.02. What is the ratio of the Rating (1=low 6=high) in Europe(developing only) in 2007 to that in 2011?
Provide a short and direct response. 0.98. What is the ratio of the Rating (1=low 6=high) in Least developed countries in 2007 to that in 2011?
Offer a very short reply. 1.01. What is the ratio of the Rating (1=low 6=high) of Sao Tome and Principe in 2007 to that in 2011?
Your answer should be very brief. 1. What is the ratio of the Rating (1=low 6=high) of Europe(developing only) in 2007 to that in 2012?
Provide a short and direct response. 1. What is the ratio of the Rating (1=low 6=high) in Least developed countries in 2007 to that in 2012?
Keep it short and to the point. 1.04. What is the ratio of the Rating (1=low 6=high) in Armenia in 2007 to that in 2012?
Offer a terse response. 0.88. What is the ratio of the Rating (1=low 6=high) in Sao Tome and Principe in 2007 to that in 2012?
Provide a succinct answer. 1. What is the ratio of the Rating (1=low 6=high) in Europe(developing only) in 2008 to that in 2009?
Ensure brevity in your answer.  1.01. What is the ratio of the Rating (1=low 6=high) in Least developed countries in 2008 to that in 2009?
Your answer should be compact. 1. What is the ratio of the Rating (1=low 6=high) of Sao Tome and Principe in 2008 to that in 2009?
Provide a short and direct response. 1. What is the ratio of the Rating (1=low 6=high) of Europe(developing only) in 2008 to that in 2010?
Offer a terse response. 1.05. What is the ratio of the Rating (1=low 6=high) of Least developed countries in 2008 to that in 2010?
Give a very brief answer. 1.01. What is the ratio of the Rating (1=low 6=high) of Sao Tome and Principe in 2008 to that in 2010?
Offer a very short reply. 1. What is the ratio of the Rating (1=low 6=high) in Europe(developing only) in 2008 to that in 2011?
Make the answer very short. 1.02. What is the ratio of the Rating (1=low 6=high) of Armenia in 2008 to that in 2011?
Offer a very short reply. 1. What is the ratio of the Rating (1=low 6=high) in Europe(developing only) in 2008 to that in 2012?
Make the answer very short. 1.04. What is the ratio of the Rating (1=low 6=high) of Least developed countries in 2008 to that in 2012?
Your answer should be compact. 1.02. What is the ratio of the Rating (1=low 6=high) in Armenia in 2008 to that in 2012?
Keep it short and to the point. 1. What is the ratio of the Rating (1=low 6=high) in Sao Tome and Principe in 2008 to that in 2012?
Keep it short and to the point. 1. What is the ratio of the Rating (1=low 6=high) of Europe(developing only) in 2009 to that in 2010?
Make the answer very short. 1.03. What is the ratio of the Rating (1=low 6=high) of Least developed countries in 2009 to that in 2010?
Provide a short and direct response. 1.01. What is the ratio of the Rating (1=low 6=high) of Europe(developing only) in 2009 to that in 2011?
Your answer should be very brief. 1. What is the ratio of the Rating (1=low 6=high) of Least developed countries in 2009 to that in 2011?
Provide a succinct answer. 1. What is the ratio of the Rating (1=low 6=high) in Armenia in 2009 to that in 2011?
Give a very brief answer. 1. What is the ratio of the Rating (1=low 6=high) of Sao Tome and Principe in 2009 to that in 2011?
Keep it short and to the point. 1. What is the ratio of the Rating (1=low 6=high) of Europe(developing only) in 2009 to that in 2012?
Make the answer very short. 1.02. What is the ratio of the Rating (1=low 6=high) of Least developed countries in 2009 to that in 2012?
Keep it short and to the point. 1.03. What is the ratio of the Rating (1=low 6=high) of Sao Tome and Principe in 2009 to that in 2012?
Offer a terse response. 1. What is the ratio of the Rating (1=low 6=high) of Europe(developing only) in 2010 to that in 2011?
Provide a short and direct response. 0.97. What is the ratio of the Rating (1=low 6=high) in Least developed countries in 2010 to that in 2011?
Keep it short and to the point. 0.99. What is the ratio of the Rating (1=low 6=high) in Armenia in 2010 to that in 2011?
Give a very brief answer. 0.88. What is the ratio of the Rating (1=low 6=high) of Sao Tome and Principe in 2010 to that in 2011?
Give a very brief answer. 1. What is the ratio of the Rating (1=low 6=high) of Europe(developing only) in 2010 to that in 2012?
Your answer should be very brief. 0.99. What is the ratio of the Rating (1=low 6=high) in Least developed countries in 2010 to that in 2012?
Make the answer very short. 1.01. What is the ratio of the Rating (1=low 6=high) of Armenia in 2010 to that in 2012?
Provide a short and direct response. 0.88. What is the ratio of the Rating (1=low 6=high) of Sao Tome and Principe in 2010 to that in 2012?
Your response must be concise. 1. What is the ratio of the Rating (1=low 6=high) of Europe(developing only) in 2011 to that in 2012?
Provide a succinct answer. 1.02. What is the ratio of the Rating (1=low 6=high) in Least developed countries in 2011 to that in 2012?
Give a very brief answer. 1.03. What is the ratio of the Rating (1=low 6=high) in Armenia in 2011 to that in 2012?
Provide a short and direct response. 1. What is the ratio of the Rating (1=low 6=high) of Sao Tome and Principe in 2011 to that in 2012?
Offer a terse response. 1. What is the difference between the highest and the second highest Rating (1=low 6=high) of Europe(developing only)?
Give a very brief answer. 0.05. What is the difference between the highest and the second highest Rating (1=low 6=high) of Least developed countries?
Your answer should be very brief. 0.01. What is the difference between the highest and the second highest Rating (1=low 6=high) of Armenia?
Ensure brevity in your answer.  0. What is the difference between the highest and the second highest Rating (1=low 6=high) in Sao Tome and Principe?
Your answer should be very brief. 0. What is the difference between the highest and the lowest Rating (1=low 6=high) of Europe(developing only)?
Provide a succinct answer. 0.16. What is the difference between the highest and the lowest Rating (1=low 6=high) in Least developed countries?
Give a very brief answer. 0.1. What is the difference between the highest and the lowest Rating (1=low 6=high) in Armenia?
Offer a terse response. 0.5. 